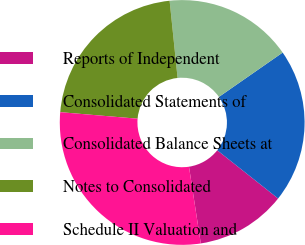<chart> <loc_0><loc_0><loc_500><loc_500><pie_chart><fcel>Reports of Independent<fcel>Consolidated Statements of<fcel>Consolidated Balance Sheets at<fcel>Notes to Consolidated<fcel>Schedule II Valuation and<nl><fcel>11.9%<fcel>20.34%<fcel>16.96%<fcel>22.02%<fcel>28.77%<nl></chart> 